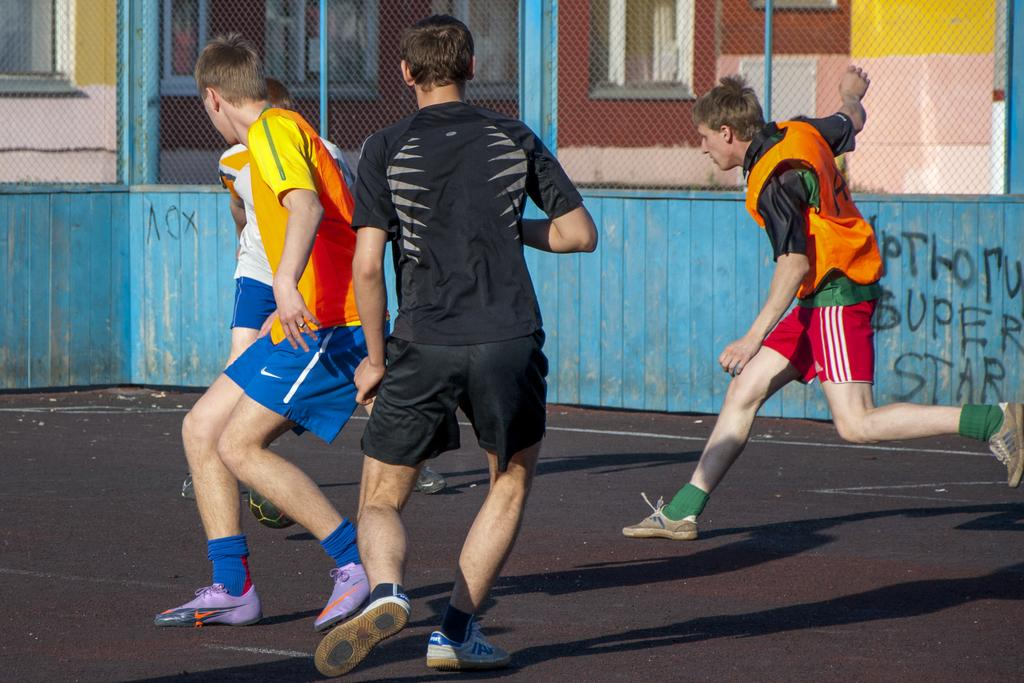Provide a one-sentence caption for the provided image. people playing soccer outside in front of a blue wall with Super Star on it. 